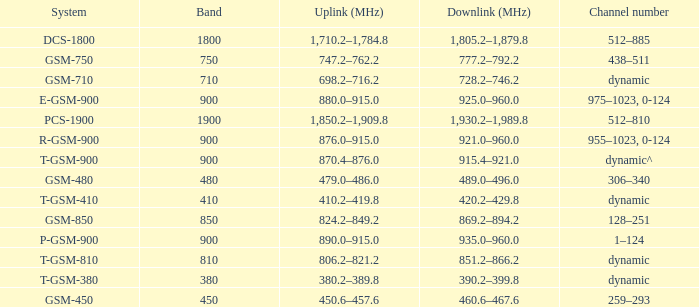What band is the highest and has a System of gsm-450? 450.0. Parse the full table. {'header': ['System', 'Band', 'Uplink (MHz)', 'Downlink (MHz)', 'Channel number'], 'rows': [['DCS-1800', '1800', '1,710.2–1,784.8', '1,805.2–1,879.8', '512–885'], ['GSM-750', '750', '747.2–762.2', '777.2–792.2', '438–511'], ['GSM-710', '710', '698.2–716.2', '728.2–746.2', 'dynamic'], ['E-GSM-900', '900', '880.0–915.0', '925.0–960.0', '975–1023, 0-124'], ['PCS-1900', '1900', '1,850.2–1,909.8', '1,930.2–1,989.8', '512–810'], ['R-GSM-900', '900', '876.0–915.0', '921.0–960.0', '955–1023, 0-124'], ['T-GSM-900', '900', '870.4–876.0', '915.4–921.0', 'dynamic^'], ['GSM-480', '480', '479.0–486.0', '489.0–496.0', '306–340'], ['T-GSM-410', '410', '410.2–419.8', '420.2–429.8', 'dynamic'], ['GSM-850', '850', '824.2–849.2', '869.2–894.2', '128–251'], ['P-GSM-900', '900', '890.0–915.0', '935.0–960.0', '1–124'], ['T-GSM-810', '810', '806.2–821.2', '851.2–866.2', 'dynamic'], ['T-GSM-380', '380', '380.2–389.8', '390.2–399.8', 'dynamic'], ['GSM-450', '450', '450.6–457.6', '460.6–467.6', '259–293']]} 